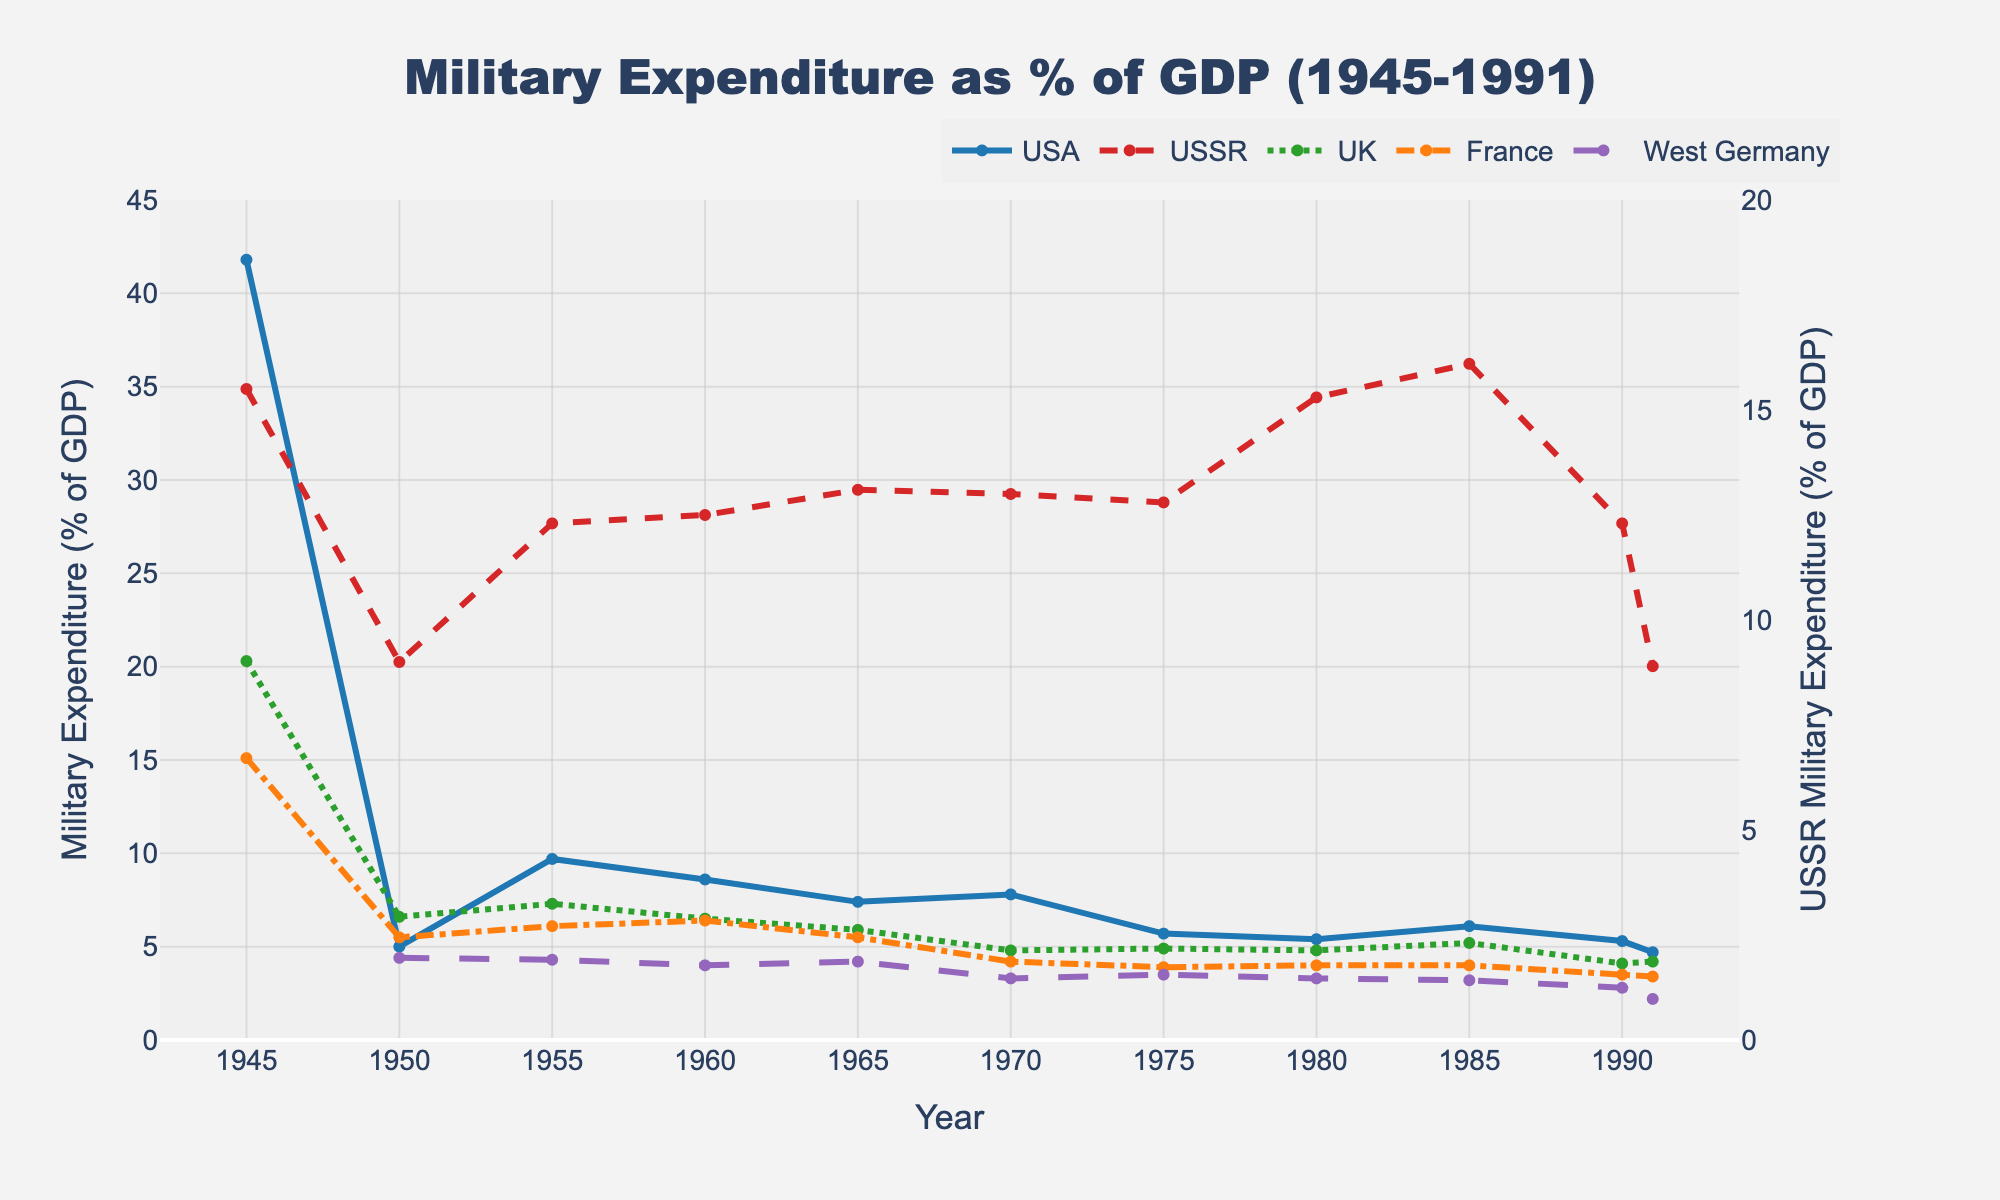What year did the USA have the highest military expenditure as a percentage of GDP? The USA had its highest military expenditure in 1945. This is evident from the peak value in the line representing the USA on the chart.
Answer: 1945 In which year did the USSR's military expenditure as a percentage of GDP surpass that of the USA for the first time? Compare the lines for the USA and the USSR. The USSR's expenditure surpasses the USA around 1955 when the USSR reaches 12.3% and the USA is at 9.7%.
Answer: 1955 By how many percentage points did the UK's military expenditure as a percentage of GDP decrease from 1945 to 1990? Subtract the UK's percentage in 1990 from that in 1945: 20.3 - 4.1 = 16.2.
Answer: 16.2 Which country had the lowest military expenditure as percentage of GDP in 1991, and what was the percentage? Check the final values for each country in 1991. West Germany has the lowest at 2.2%.
Answer: West Germany with 2.2% How did France's military expenditure trend compare to that of the UK between 1980 and 1991? The line for France remains relatively stable, slightly decreasing from 4.0 to 3.4. The UK's line also shows a slight decrease from 4.8 to 4.2. Both countries show a similar decreasing trend.
Answer: Both decreased slightly What was the average military expenditure as a percentage of GDP for West Germany across the entire timeline? Find the sum of West Germany's expenditures (4.4, 4.3, 4.0, 4.2, 3.3, 3.5, 3.3, 3.2, 2.8, 2.2) and divide by the number of data points: (4.4 + 4.3 + 4.0 + 4.2 + 3.3 + 3.5 + 3.3 + 3.2 + 2.8 + 2.2)/10 = 3.42.
Answer: 3.42 In what year was the disparity between the USA and USSR's military expenditure as a percentage of GDP the greatest? Calculate the absolute differences for each year. The greatest difference is in 1945 (41.8 - 15.5 = 26.3).
Answer: 1945 Compare the trends of military expenditure as a percentage of GDP for the USSR and the USA from 1980 to 1991. The USSR shows a peak in 1985 at 16.1% and falls to 8.9% by 1991. The USA remains relatively stable with minor fluctuations, starting at 5.4% in 1980 and ending at 4.7% in 1991. The USSR's trend shows a steep decline, while the USA's remains steady.
Answer: Steep decline for USSR, steady for USA Which country experienced the most significant change in military expenditure as a percentage of GDP from 1980 to 1985? Compare the changes for each country. The USSR experienced the most significant change, increasing from 15.3% to 16.1%.
Answer: USSR 